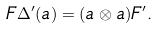Convert formula to latex. <formula><loc_0><loc_0><loc_500><loc_500>F \Delta ^ { \prime } ( a ) = ( a \otimes a ) F ^ { \prime } .</formula> 